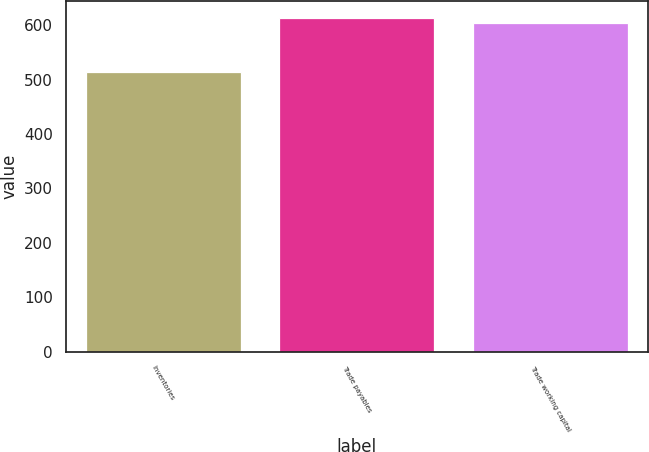Convert chart. <chart><loc_0><loc_0><loc_500><loc_500><bar_chart><fcel>Inventories<fcel>Trade payables<fcel>Trade working capital<nl><fcel>514<fcel>614<fcel>604<nl></chart> 